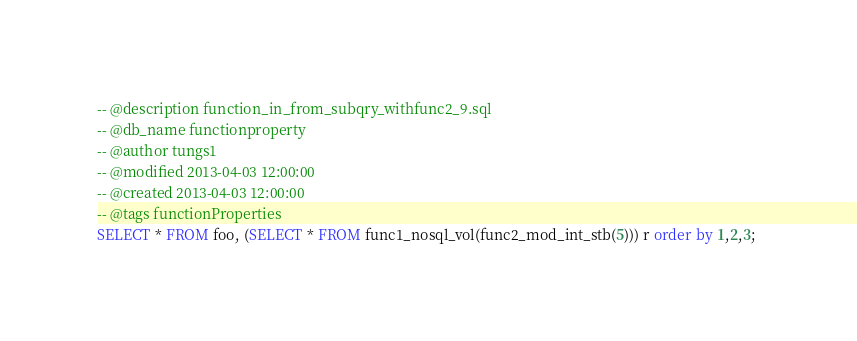Convert code to text. <code><loc_0><loc_0><loc_500><loc_500><_SQL_>-- @description function_in_from_subqry_withfunc2_9.sql
-- @db_name functionproperty
-- @author tungs1
-- @modified 2013-04-03 12:00:00
-- @created 2013-04-03 12:00:00
-- @tags functionProperties 
SELECT * FROM foo, (SELECT * FROM func1_nosql_vol(func2_mod_int_stb(5))) r order by 1,2,3; 
</code> 